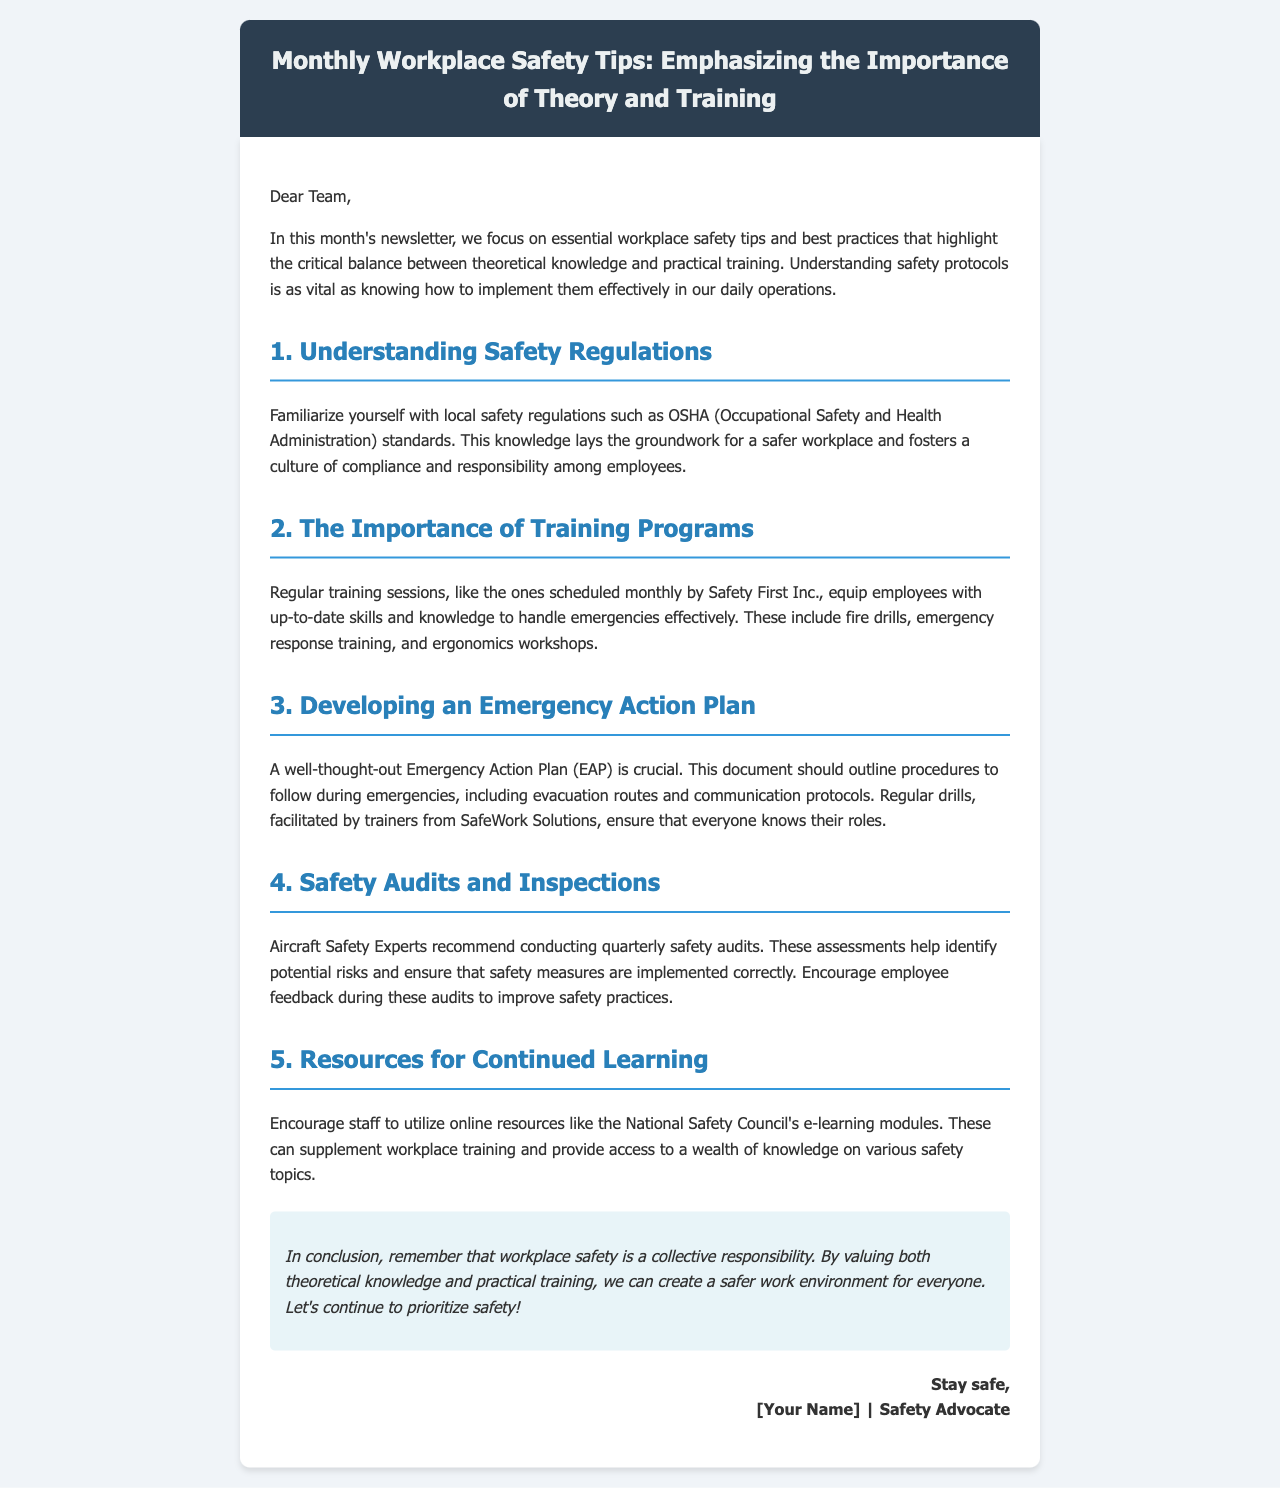What is the title of the newsletter? The title of the newsletter is presented prominently at the top of the document.
Answer: Monthly Workplace Safety Tips: Emphasizing the Importance of Theory and Training Who is the author of the newsletter? The author's name is included at the end of the document in the sign-off section.
Answer: [Your Name] What organization conducts regular training sessions? The organization that schedules these sessions is identified in the content of the newsletter.
Answer: Safety First Inc What is one resource mentioned for continued learning? A specific online resource is recommended in the document for ongoing education on safety topics.
Answer: National Safety Council's e-learning modules How often should safety audits be conducted? The document specifies the frequency at which safety audits should take place.
Answer: Quarterly What is the purpose of an Emergency Action Plan? The document mentions the reason why an Emergency Action Plan is important.
Answer: Outline procedures during emergencies Name one type of training mentioned in the newsletter. A specific type of training is listed in the section regarding training programs.
Answer: Fire drills What does the conclusion emphasize about workplace safety? The conclusion provides a key takeaway regarding the collective responsibility for safety.
Answer: A collective responsibility 